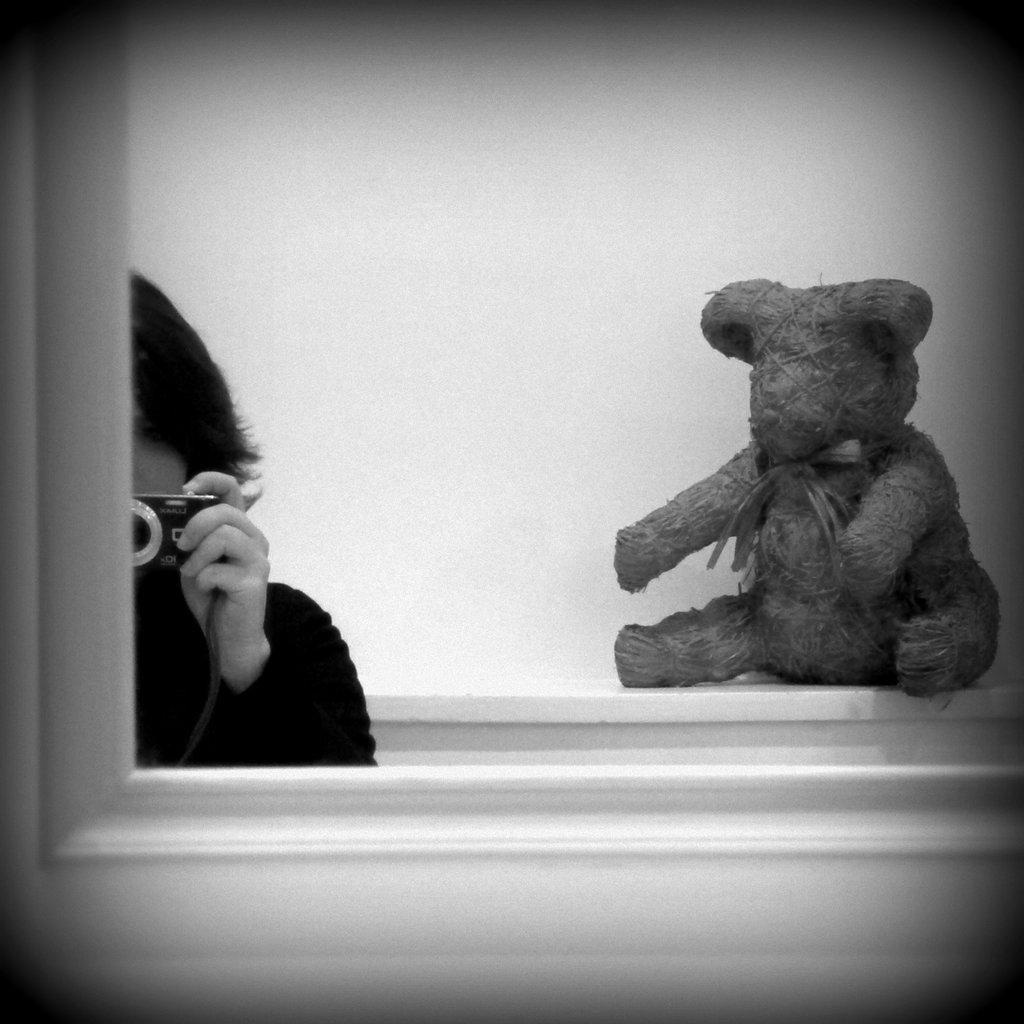What is located in the foreground of the image? There is a mirror in the foreground of the image. What can be seen in the reflection of the mirror? A person holding a camera is visible on the left side of the mirror, and a doll is on the right side of the mirror, near a wall. What type of noise does the cast make in the image? There is no cast present in the image, so it is not possible to determine what noise it might make. 